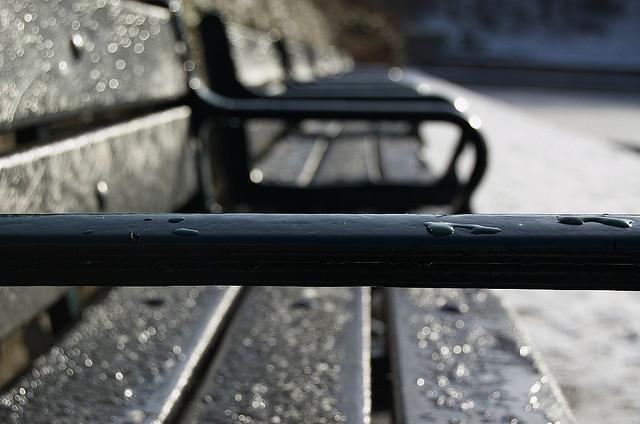How many benches are visible?
Give a very brief answer. 2. 